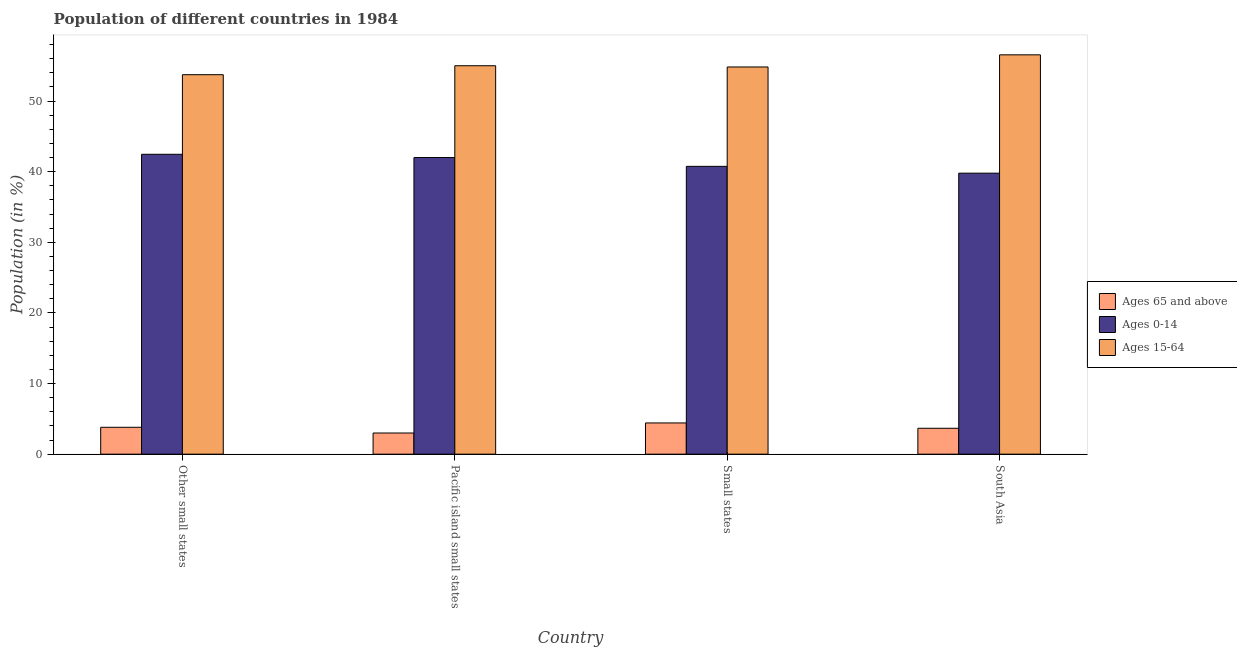How many different coloured bars are there?
Your answer should be compact. 3. Are the number of bars on each tick of the X-axis equal?
Make the answer very short. Yes. What is the label of the 1st group of bars from the left?
Provide a short and direct response. Other small states. In how many cases, is the number of bars for a given country not equal to the number of legend labels?
Make the answer very short. 0. What is the percentage of population within the age-group 15-64 in Pacific island small states?
Your answer should be very brief. 55. Across all countries, what is the maximum percentage of population within the age-group 0-14?
Offer a very short reply. 42.46. Across all countries, what is the minimum percentage of population within the age-group 0-14?
Make the answer very short. 39.79. In which country was the percentage of population within the age-group 15-64 maximum?
Provide a succinct answer. South Asia. In which country was the percentage of population within the age-group of 65 and above minimum?
Ensure brevity in your answer.  Pacific island small states. What is the total percentage of population within the age-group of 65 and above in the graph?
Give a very brief answer. 14.89. What is the difference between the percentage of population within the age-group 0-14 in Other small states and that in Small states?
Your response must be concise. 1.71. What is the difference between the percentage of population within the age-group of 65 and above in Pacific island small states and the percentage of population within the age-group 0-14 in Other small states?
Make the answer very short. -39.47. What is the average percentage of population within the age-group 15-64 per country?
Your answer should be compact. 55.03. What is the difference between the percentage of population within the age-group of 65 and above and percentage of population within the age-group 15-64 in South Asia?
Ensure brevity in your answer.  -52.88. In how many countries, is the percentage of population within the age-group 15-64 greater than 38 %?
Keep it short and to the point. 4. What is the ratio of the percentage of population within the age-group of 65 and above in Pacific island small states to that in South Asia?
Your answer should be compact. 0.82. Is the percentage of population within the age-group 0-14 in Small states less than that in South Asia?
Your response must be concise. No. Is the difference between the percentage of population within the age-group of 65 and above in Other small states and South Asia greater than the difference between the percentage of population within the age-group 0-14 in Other small states and South Asia?
Give a very brief answer. No. What is the difference between the highest and the second highest percentage of population within the age-group 0-14?
Your response must be concise. 0.46. What is the difference between the highest and the lowest percentage of population within the age-group 0-14?
Keep it short and to the point. 2.67. Is the sum of the percentage of population within the age-group 15-64 in Pacific island small states and South Asia greater than the maximum percentage of population within the age-group 0-14 across all countries?
Make the answer very short. Yes. What does the 1st bar from the left in South Asia represents?
Ensure brevity in your answer.  Ages 65 and above. What does the 3rd bar from the right in Other small states represents?
Offer a terse response. Ages 65 and above. Is it the case that in every country, the sum of the percentage of population within the age-group of 65 and above and percentage of population within the age-group 0-14 is greater than the percentage of population within the age-group 15-64?
Offer a terse response. No. How many bars are there?
Make the answer very short. 12. How many countries are there in the graph?
Ensure brevity in your answer.  4. What is the difference between two consecutive major ticks on the Y-axis?
Ensure brevity in your answer.  10. Are the values on the major ticks of Y-axis written in scientific E-notation?
Your response must be concise. No. Does the graph contain any zero values?
Your answer should be very brief. No. Does the graph contain grids?
Keep it short and to the point. No. Where does the legend appear in the graph?
Provide a short and direct response. Center right. How many legend labels are there?
Give a very brief answer. 3. What is the title of the graph?
Provide a succinct answer. Population of different countries in 1984. Does "Textiles and clothing" appear as one of the legend labels in the graph?
Provide a succinct answer. No. What is the label or title of the X-axis?
Provide a succinct answer. Country. What is the label or title of the Y-axis?
Provide a short and direct response. Population (in %). What is the Population (in %) in Ages 65 and above in Other small states?
Provide a short and direct response. 3.81. What is the Population (in %) in Ages 0-14 in Other small states?
Provide a short and direct response. 42.46. What is the Population (in %) of Ages 15-64 in Other small states?
Your answer should be compact. 53.73. What is the Population (in %) in Ages 65 and above in Pacific island small states?
Ensure brevity in your answer.  3. What is the Population (in %) in Ages 0-14 in Pacific island small states?
Your response must be concise. 42. What is the Population (in %) of Ages 15-64 in Pacific island small states?
Offer a terse response. 55. What is the Population (in %) of Ages 65 and above in Small states?
Your response must be concise. 4.42. What is the Population (in %) of Ages 0-14 in Small states?
Your response must be concise. 40.75. What is the Population (in %) of Ages 15-64 in Small states?
Give a very brief answer. 54.82. What is the Population (in %) of Ages 65 and above in South Asia?
Your answer should be very brief. 3.67. What is the Population (in %) of Ages 0-14 in South Asia?
Give a very brief answer. 39.79. What is the Population (in %) in Ages 15-64 in South Asia?
Your answer should be very brief. 56.54. Across all countries, what is the maximum Population (in %) of Ages 65 and above?
Make the answer very short. 4.42. Across all countries, what is the maximum Population (in %) in Ages 0-14?
Your answer should be compact. 42.46. Across all countries, what is the maximum Population (in %) in Ages 15-64?
Give a very brief answer. 56.54. Across all countries, what is the minimum Population (in %) of Ages 65 and above?
Ensure brevity in your answer.  3. Across all countries, what is the minimum Population (in %) in Ages 0-14?
Provide a succinct answer. 39.79. Across all countries, what is the minimum Population (in %) of Ages 15-64?
Make the answer very short. 53.73. What is the total Population (in %) of Ages 65 and above in the graph?
Provide a succinct answer. 14.89. What is the total Population (in %) of Ages 0-14 in the graph?
Your answer should be compact. 165.01. What is the total Population (in %) in Ages 15-64 in the graph?
Give a very brief answer. 220.1. What is the difference between the Population (in %) of Ages 65 and above in Other small states and that in Pacific island small states?
Offer a very short reply. 0.81. What is the difference between the Population (in %) in Ages 0-14 in Other small states and that in Pacific island small states?
Ensure brevity in your answer.  0.46. What is the difference between the Population (in %) in Ages 15-64 in Other small states and that in Pacific island small states?
Give a very brief answer. -1.27. What is the difference between the Population (in %) in Ages 65 and above in Other small states and that in Small states?
Offer a very short reply. -0.62. What is the difference between the Population (in %) of Ages 0-14 in Other small states and that in Small states?
Ensure brevity in your answer.  1.71. What is the difference between the Population (in %) in Ages 15-64 in Other small states and that in Small states?
Offer a very short reply. -1.09. What is the difference between the Population (in %) of Ages 65 and above in Other small states and that in South Asia?
Offer a very short reply. 0.14. What is the difference between the Population (in %) in Ages 0-14 in Other small states and that in South Asia?
Offer a terse response. 2.67. What is the difference between the Population (in %) of Ages 15-64 in Other small states and that in South Asia?
Offer a very short reply. -2.81. What is the difference between the Population (in %) of Ages 65 and above in Pacific island small states and that in Small states?
Keep it short and to the point. -1.43. What is the difference between the Population (in %) in Ages 0-14 in Pacific island small states and that in Small states?
Keep it short and to the point. 1.25. What is the difference between the Population (in %) of Ages 15-64 in Pacific island small states and that in Small states?
Your response must be concise. 0.18. What is the difference between the Population (in %) of Ages 65 and above in Pacific island small states and that in South Asia?
Your answer should be very brief. -0.67. What is the difference between the Population (in %) of Ages 0-14 in Pacific island small states and that in South Asia?
Offer a terse response. 2.21. What is the difference between the Population (in %) of Ages 15-64 in Pacific island small states and that in South Asia?
Give a very brief answer. -1.54. What is the difference between the Population (in %) of Ages 65 and above in Small states and that in South Asia?
Offer a very short reply. 0.75. What is the difference between the Population (in %) of Ages 0-14 in Small states and that in South Asia?
Your answer should be compact. 0.96. What is the difference between the Population (in %) in Ages 15-64 in Small states and that in South Asia?
Your answer should be compact. -1.72. What is the difference between the Population (in %) of Ages 65 and above in Other small states and the Population (in %) of Ages 0-14 in Pacific island small states?
Keep it short and to the point. -38.2. What is the difference between the Population (in %) in Ages 65 and above in Other small states and the Population (in %) in Ages 15-64 in Pacific island small states?
Provide a succinct answer. -51.2. What is the difference between the Population (in %) of Ages 0-14 in Other small states and the Population (in %) of Ages 15-64 in Pacific island small states?
Give a very brief answer. -12.54. What is the difference between the Population (in %) in Ages 65 and above in Other small states and the Population (in %) in Ages 0-14 in Small states?
Offer a terse response. -36.95. What is the difference between the Population (in %) in Ages 65 and above in Other small states and the Population (in %) in Ages 15-64 in Small states?
Your response must be concise. -51.02. What is the difference between the Population (in %) in Ages 0-14 in Other small states and the Population (in %) in Ages 15-64 in Small states?
Your answer should be very brief. -12.36. What is the difference between the Population (in %) in Ages 65 and above in Other small states and the Population (in %) in Ages 0-14 in South Asia?
Offer a terse response. -35.98. What is the difference between the Population (in %) of Ages 65 and above in Other small states and the Population (in %) of Ages 15-64 in South Asia?
Provide a short and direct response. -52.74. What is the difference between the Population (in %) in Ages 0-14 in Other small states and the Population (in %) in Ages 15-64 in South Asia?
Provide a short and direct response. -14.08. What is the difference between the Population (in %) in Ages 65 and above in Pacific island small states and the Population (in %) in Ages 0-14 in Small states?
Give a very brief answer. -37.76. What is the difference between the Population (in %) in Ages 65 and above in Pacific island small states and the Population (in %) in Ages 15-64 in Small states?
Give a very brief answer. -51.83. What is the difference between the Population (in %) of Ages 0-14 in Pacific island small states and the Population (in %) of Ages 15-64 in Small states?
Offer a terse response. -12.82. What is the difference between the Population (in %) of Ages 65 and above in Pacific island small states and the Population (in %) of Ages 0-14 in South Asia?
Ensure brevity in your answer.  -36.79. What is the difference between the Population (in %) of Ages 65 and above in Pacific island small states and the Population (in %) of Ages 15-64 in South Asia?
Provide a succinct answer. -53.55. What is the difference between the Population (in %) in Ages 0-14 in Pacific island small states and the Population (in %) in Ages 15-64 in South Asia?
Make the answer very short. -14.54. What is the difference between the Population (in %) in Ages 65 and above in Small states and the Population (in %) in Ages 0-14 in South Asia?
Give a very brief answer. -35.37. What is the difference between the Population (in %) in Ages 65 and above in Small states and the Population (in %) in Ages 15-64 in South Asia?
Provide a succinct answer. -52.12. What is the difference between the Population (in %) in Ages 0-14 in Small states and the Population (in %) in Ages 15-64 in South Asia?
Keep it short and to the point. -15.79. What is the average Population (in %) in Ages 65 and above per country?
Your response must be concise. 3.72. What is the average Population (in %) in Ages 0-14 per country?
Offer a very short reply. 41.25. What is the average Population (in %) of Ages 15-64 per country?
Make the answer very short. 55.03. What is the difference between the Population (in %) of Ages 65 and above and Population (in %) of Ages 0-14 in Other small states?
Your answer should be compact. -38.66. What is the difference between the Population (in %) of Ages 65 and above and Population (in %) of Ages 15-64 in Other small states?
Your answer should be compact. -49.93. What is the difference between the Population (in %) of Ages 0-14 and Population (in %) of Ages 15-64 in Other small states?
Your answer should be very brief. -11.27. What is the difference between the Population (in %) in Ages 65 and above and Population (in %) in Ages 0-14 in Pacific island small states?
Offer a very short reply. -39.01. What is the difference between the Population (in %) of Ages 65 and above and Population (in %) of Ages 15-64 in Pacific island small states?
Give a very brief answer. -52. What is the difference between the Population (in %) of Ages 0-14 and Population (in %) of Ages 15-64 in Pacific island small states?
Keep it short and to the point. -13. What is the difference between the Population (in %) in Ages 65 and above and Population (in %) in Ages 0-14 in Small states?
Give a very brief answer. -36.33. What is the difference between the Population (in %) in Ages 65 and above and Population (in %) in Ages 15-64 in Small states?
Offer a terse response. -50.4. What is the difference between the Population (in %) of Ages 0-14 and Population (in %) of Ages 15-64 in Small states?
Your answer should be compact. -14.07. What is the difference between the Population (in %) in Ages 65 and above and Population (in %) in Ages 0-14 in South Asia?
Offer a terse response. -36.12. What is the difference between the Population (in %) in Ages 65 and above and Population (in %) in Ages 15-64 in South Asia?
Make the answer very short. -52.88. What is the difference between the Population (in %) in Ages 0-14 and Population (in %) in Ages 15-64 in South Asia?
Give a very brief answer. -16.75. What is the ratio of the Population (in %) in Ages 65 and above in Other small states to that in Pacific island small states?
Keep it short and to the point. 1.27. What is the ratio of the Population (in %) in Ages 0-14 in Other small states to that in Pacific island small states?
Provide a short and direct response. 1.01. What is the ratio of the Population (in %) in Ages 15-64 in Other small states to that in Pacific island small states?
Keep it short and to the point. 0.98. What is the ratio of the Population (in %) in Ages 65 and above in Other small states to that in Small states?
Your answer should be compact. 0.86. What is the ratio of the Population (in %) of Ages 0-14 in Other small states to that in Small states?
Make the answer very short. 1.04. What is the ratio of the Population (in %) in Ages 15-64 in Other small states to that in Small states?
Offer a very short reply. 0.98. What is the ratio of the Population (in %) in Ages 65 and above in Other small states to that in South Asia?
Offer a very short reply. 1.04. What is the ratio of the Population (in %) of Ages 0-14 in Other small states to that in South Asia?
Your response must be concise. 1.07. What is the ratio of the Population (in %) of Ages 15-64 in Other small states to that in South Asia?
Provide a succinct answer. 0.95. What is the ratio of the Population (in %) in Ages 65 and above in Pacific island small states to that in Small states?
Offer a very short reply. 0.68. What is the ratio of the Population (in %) in Ages 0-14 in Pacific island small states to that in Small states?
Offer a terse response. 1.03. What is the ratio of the Population (in %) in Ages 15-64 in Pacific island small states to that in Small states?
Ensure brevity in your answer.  1. What is the ratio of the Population (in %) of Ages 65 and above in Pacific island small states to that in South Asia?
Give a very brief answer. 0.82. What is the ratio of the Population (in %) in Ages 0-14 in Pacific island small states to that in South Asia?
Offer a very short reply. 1.06. What is the ratio of the Population (in %) of Ages 15-64 in Pacific island small states to that in South Asia?
Keep it short and to the point. 0.97. What is the ratio of the Population (in %) in Ages 65 and above in Small states to that in South Asia?
Your response must be concise. 1.21. What is the ratio of the Population (in %) of Ages 0-14 in Small states to that in South Asia?
Give a very brief answer. 1.02. What is the ratio of the Population (in %) of Ages 15-64 in Small states to that in South Asia?
Your answer should be compact. 0.97. What is the difference between the highest and the second highest Population (in %) in Ages 65 and above?
Your answer should be compact. 0.62. What is the difference between the highest and the second highest Population (in %) in Ages 0-14?
Provide a short and direct response. 0.46. What is the difference between the highest and the second highest Population (in %) in Ages 15-64?
Provide a succinct answer. 1.54. What is the difference between the highest and the lowest Population (in %) in Ages 65 and above?
Make the answer very short. 1.43. What is the difference between the highest and the lowest Population (in %) of Ages 0-14?
Keep it short and to the point. 2.67. What is the difference between the highest and the lowest Population (in %) of Ages 15-64?
Offer a terse response. 2.81. 